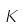Convert formula to latex. <formula><loc_0><loc_0><loc_500><loc_500>K</formula> 